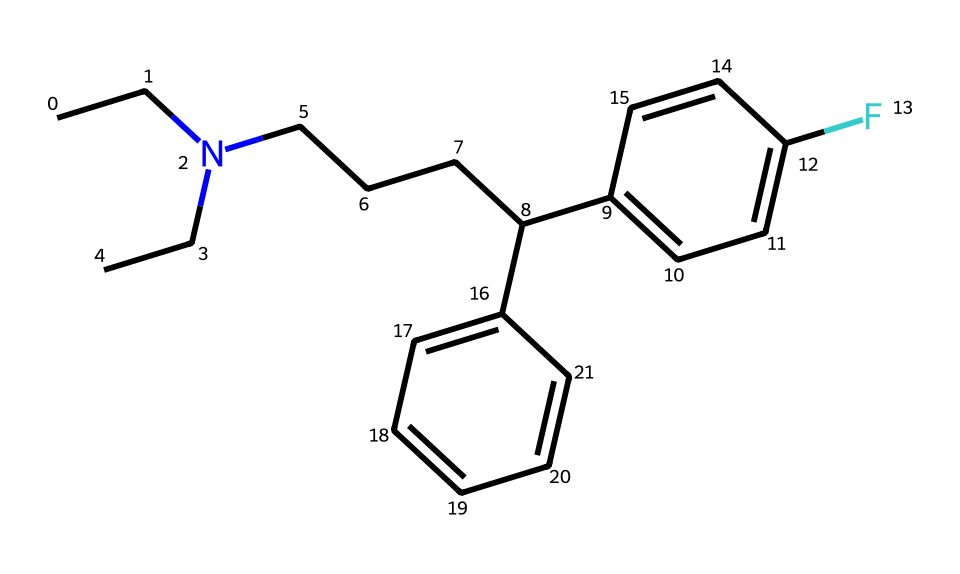What is the molecular formula of this compound? To determine the molecular formula, count the number of each type of atom present in the SMILES string. From the SMILES, we identify the atoms: there are 19 carbon (C) atoms, 24 hydrogen (H) atoms, and 1 nitrogen (N) atom. Therefore, the molecular formula is C19H24N.
Answer: C19H24N How many rings are present in this chemical structure? Inspecting the SMILES representation, there are two segments that indicate aromatic rings (the c's), but overall, there are no additional cyclic structures in the entire compound. Thus, there are zero non-aromatic rings in this structure.
Answer: 0 What type of molecular architecture characterizes this drug? The presence of a nitrogen atom bonded to a carbon chain and an aromatic system with fluorine indicates it is designed as a selective serotonin reuptake inhibitor (SSRI). This architecture typically consists of a three-dimensional structure that facilitates interaction with serotonin transporters.
Answer: SSRI What substituent is featured on the aromatic ring? Analyzing the SMILES, we find the fluorine (F) atom attached to the benzene ring, which is a common substituent in many SSRIs, enhancing their pharmacological properties.
Answer: fluorine How many distinct carbon chains are found in this structure? By examining the structure, we differentiate between the branching alkyl chain (from the nitrogen) and the two aromatic rings. There are two distinct carbon chains: one connected to the nitrogen and the other part of the aromatic system.
Answer: 2 What does the nitrogen atom's presence suggest about the compound's function? The nitrogen atom indicates a functional group typical in drugs that interact with neurotransmitter systems, such as those acting as SSRIs. It provides insight into the drug's binding affinity to serotonin receptors.
Answer: neurotransmitter How many hydrogen atoms are associated with the nitrogen in this structure? The nitrogen is bonded to two carbon chains in addition to being associated with the aromatic structures but has no direct hydrogen attachments in the SMILES representation. Thus, the total count for hydrogen connected directly to the nitrogen is zero.
Answer: 0 